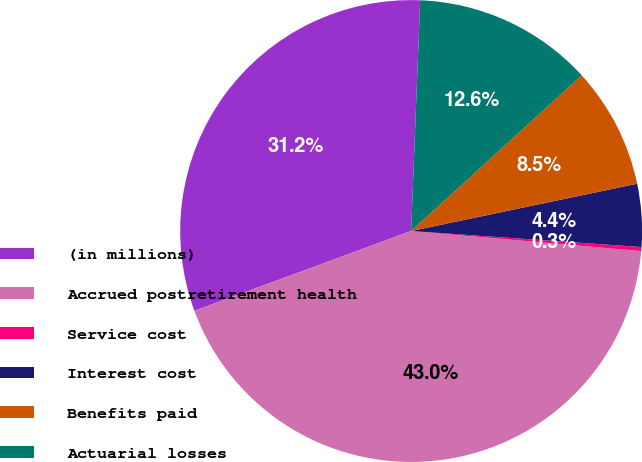Convert chart. <chart><loc_0><loc_0><loc_500><loc_500><pie_chart><fcel>(in millions)<fcel>Accrued postretirement health<fcel>Service cost<fcel>Interest cost<fcel>Benefits paid<fcel>Actuarial losses<nl><fcel>31.24%<fcel>43.0%<fcel>0.28%<fcel>4.39%<fcel>8.49%<fcel>12.6%<nl></chart> 